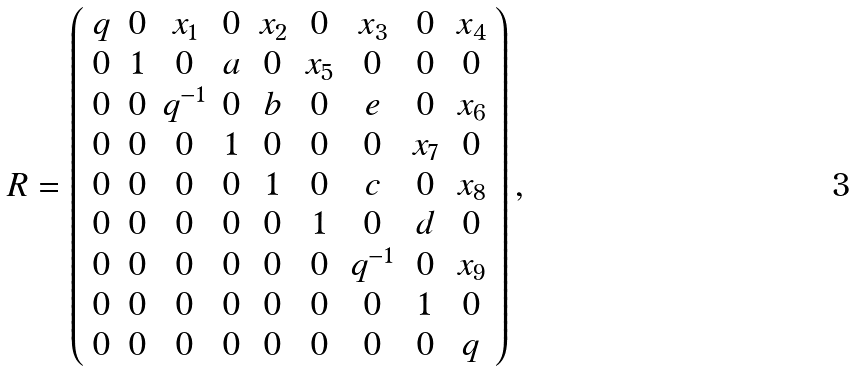Convert formula to latex. <formula><loc_0><loc_0><loc_500><loc_500>R = \left ( \begin{array} { c c c c c c c c c } q & 0 & x _ { 1 } & 0 & x _ { 2 } & 0 & x _ { 3 } & 0 & x _ { 4 } \\ 0 & 1 & 0 & a & 0 & x _ { 5 } & 0 & 0 & 0 \\ 0 & 0 & q ^ { - 1 } & 0 & b & 0 & e & 0 & x _ { 6 } \\ 0 & 0 & 0 & 1 & 0 & 0 & 0 & x _ { 7 } & 0 \\ 0 & 0 & 0 & 0 & 1 & 0 & c & 0 & x _ { 8 } \\ 0 & 0 & 0 & 0 & 0 & 1 & 0 & d & 0 \\ 0 & 0 & 0 & 0 & 0 & 0 & q ^ { - 1 } & 0 & x _ { 9 } \\ 0 & 0 & 0 & 0 & 0 & 0 & 0 & 1 & 0 \\ 0 & 0 & 0 & 0 & 0 & 0 & 0 & 0 & q \end{array} \right ) ,</formula> 